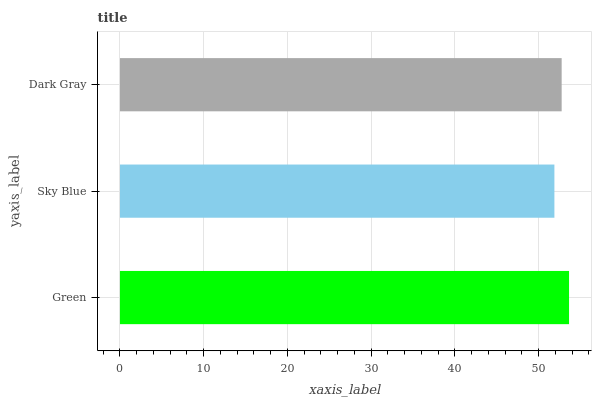Is Sky Blue the minimum?
Answer yes or no. Yes. Is Green the maximum?
Answer yes or no. Yes. Is Dark Gray the minimum?
Answer yes or no. No. Is Dark Gray the maximum?
Answer yes or no. No. Is Dark Gray greater than Sky Blue?
Answer yes or no. Yes. Is Sky Blue less than Dark Gray?
Answer yes or no. Yes. Is Sky Blue greater than Dark Gray?
Answer yes or no. No. Is Dark Gray less than Sky Blue?
Answer yes or no. No. Is Dark Gray the high median?
Answer yes or no. Yes. Is Dark Gray the low median?
Answer yes or no. Yes. Is Sky Blue the high median?
Answer yes or no. No. Is Green the low median?
Answer yes or no. No. 